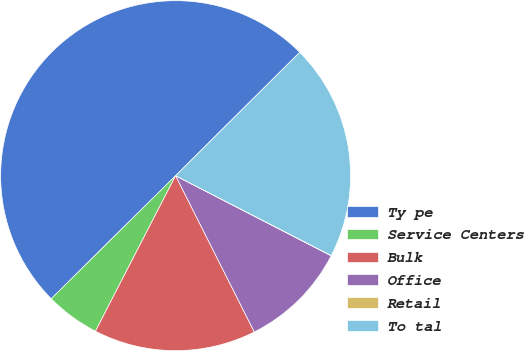<chart> <loc_0><loc_0><loc_500><loc_500><pie_chart><fcel>Ty pe<fcel>Service Centers<fcel>Bulk<fcel>Office<fcel>Retail<fcel>To tal<nl><fcel>49.97%<fcel>5.01%<fcel>15.0%<fcel>10.01%<fcel>0.02%<fcel>20.0%<nl></chart> 